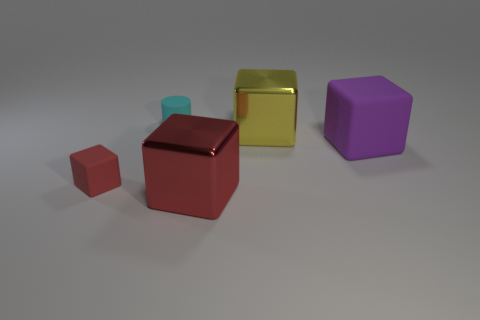There is another tiny object that is the same material as the small cyan thing; what color is it?
Ensure brevity in your answer.  Red. Are there more yellow objects than rubber cubes?
Offer a very short reply. No. Is there a large purple matte block?
Offer a terse response. Yes. The large shiny thing right of the big block that is to the left of the yellow thing is what shape?
Ensure brevity in your answer.  Cube. How many objects are small cyan cylinders or red matte objects that are in front of the small matte cylinder?
Your answer should be compact. 2. The matte cube right of the rubber block that is on the left side of the yellow metallic thing that is right of the large red shiny thing is what color?
Offer a very short reply. Purple. There is a small red object that is the same shape as the purple object; what is it made of?
Your answer should be very brief. Rubber. The big matte block has what color?
Keep it short and to the point. Purple. What number of metallic objects are cyan objects or large things?
Make the answer very short. 2. There is a shiny object in front of the large yellow shiny object that is on the right side of the tiny rubber cylinder; is there a cube to the left of it?
Provide a short and direct response. Yes. 